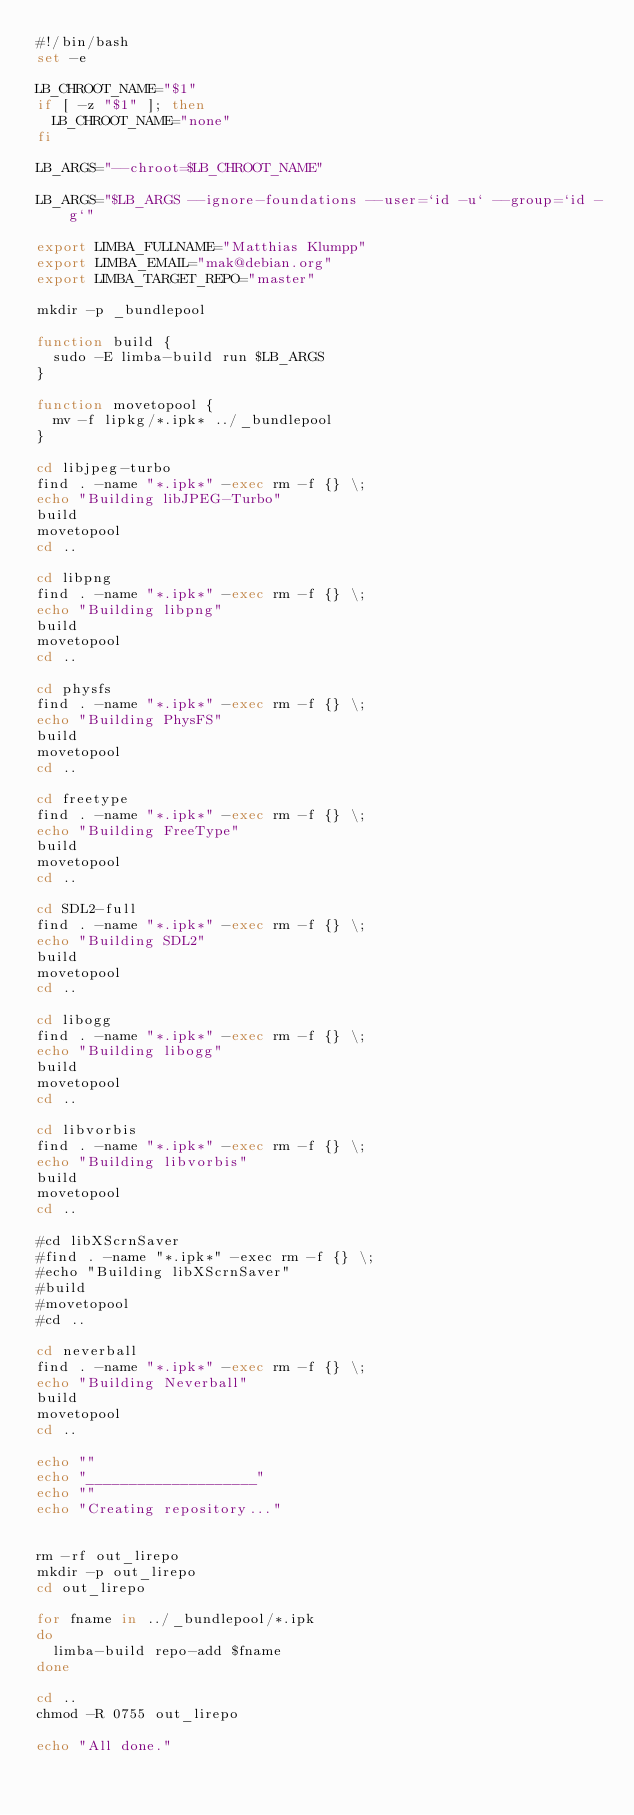Convert code to text. <code><loc_0><loc_0><loc_500><loc_500><_Bash_>#!/bin/bash
set -e

LB_CHROOT_NAME="$1"
if [ -z "$1" ]; then
  LB_CHROOT_NAME="none"
fi

LB_ARGS="--chroot=$LB_CHROOT_NAME"

LB_ARGS="$LB_ARGS --ignore-foundations --user=`id -u` --group=`id -g`"

export LIMBA_FULLNAME="Matthias Klumpp"
export LIMBA_EMAIL="mak@debian.org"
export LIMBA_TARGET_REPO="master"

mkdir -p _bundlepool

function build {
  sudo -E limba-build run $LB_ARGS
}

function movetopool {
  mv -f lipkg/*.ipk* ../_bundlepool
}

cd libjpeg-turbo
find . -name "*.ipk*" -exec rm -f {} \;
echo "Building libJPEG-Turbo"
build
movetopool
cd ..

cd libpng
find . -name "*.ipk*" -exec rm -f {} \;
echo "Building libpng"
build
movetopool
cd ..

cd physfs
find . -name "*.ipk*" -exec rm -f {} \;
echo "Building PhysFS"
build
movetopool
cd ..

cd freetype
find . -name "*.ipk*" -exec rm -f {} \;
echo "Building FreeType"
build
movetopool
cd ..

cd SDL2-full
find . -name "*.ipk*" -exec rm -f {} \;
echo "Building SDL2"
build
movetopool
cd ..

cd libogg
find . -name "*.ipk*" -exec rm -f {} \;
echo "Building libogg"
build
movetopool
cd ..

cd libvorbis
find . -name "*.ipk*" -exec rm -f {} \;
echo "Building libvorbis"
build
movetopool
cd ..

#cd libXScrnSaver
#find . -name "*.ipk*" -exec rm -f {} \;
#echo "Building libXScrnSaver"
#build
#movetopool
#cd ..

cd neverball
find . -name "*.ipk*" -exec rm -f {} \;
echo "Building Neverball"
build
movetopool
cd ..

echo ""
echo "____________________"
echo ""
echo "Creating repository..."


rm -rf out_lirepo
mkdir -p out_lirepo
cd out_lirepo

for fname in ../_bundlepool/*.ipk
do
  limba-build repo-add $fname
done

cd ..
chmod -R 0755 out_lirepo

echo "All done."
</code> 